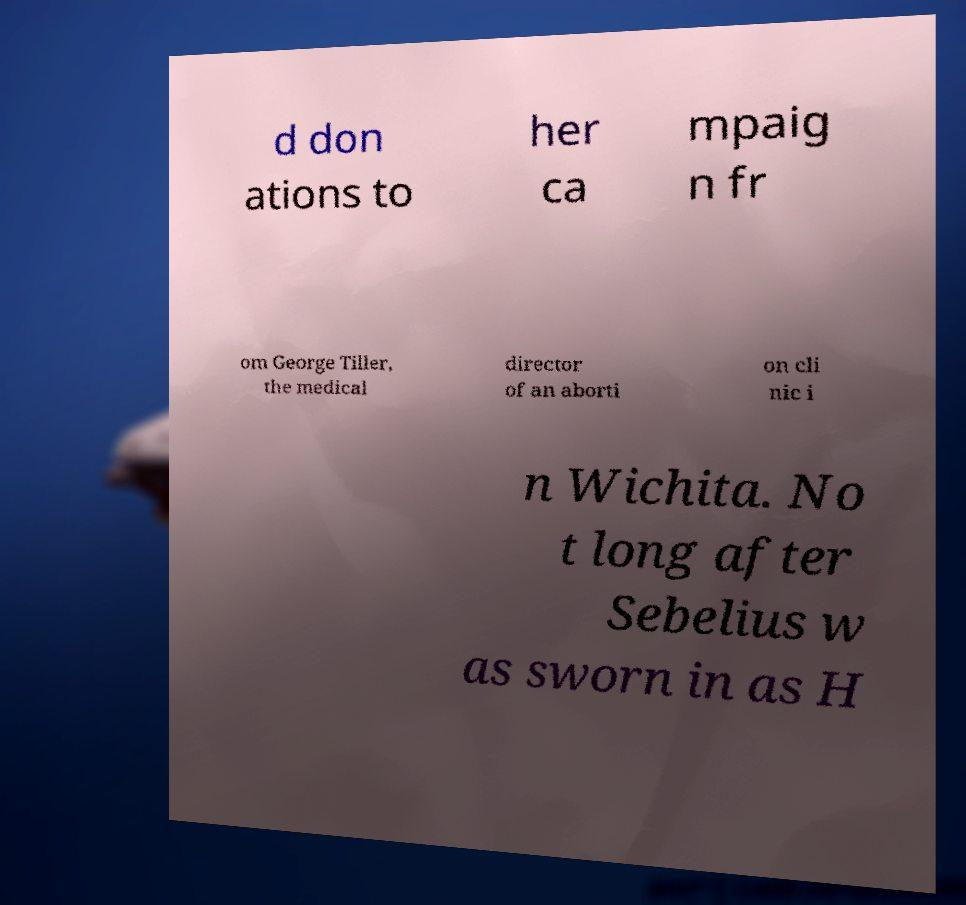For documentation purposes, I need the text within this image transcribed. Could you provide that? d don ations to her ca mpaig n fr om George Tiller, the medical director of an aborti on cli nic i n Wichita. No t long after Sebelius w as sworn in as H 